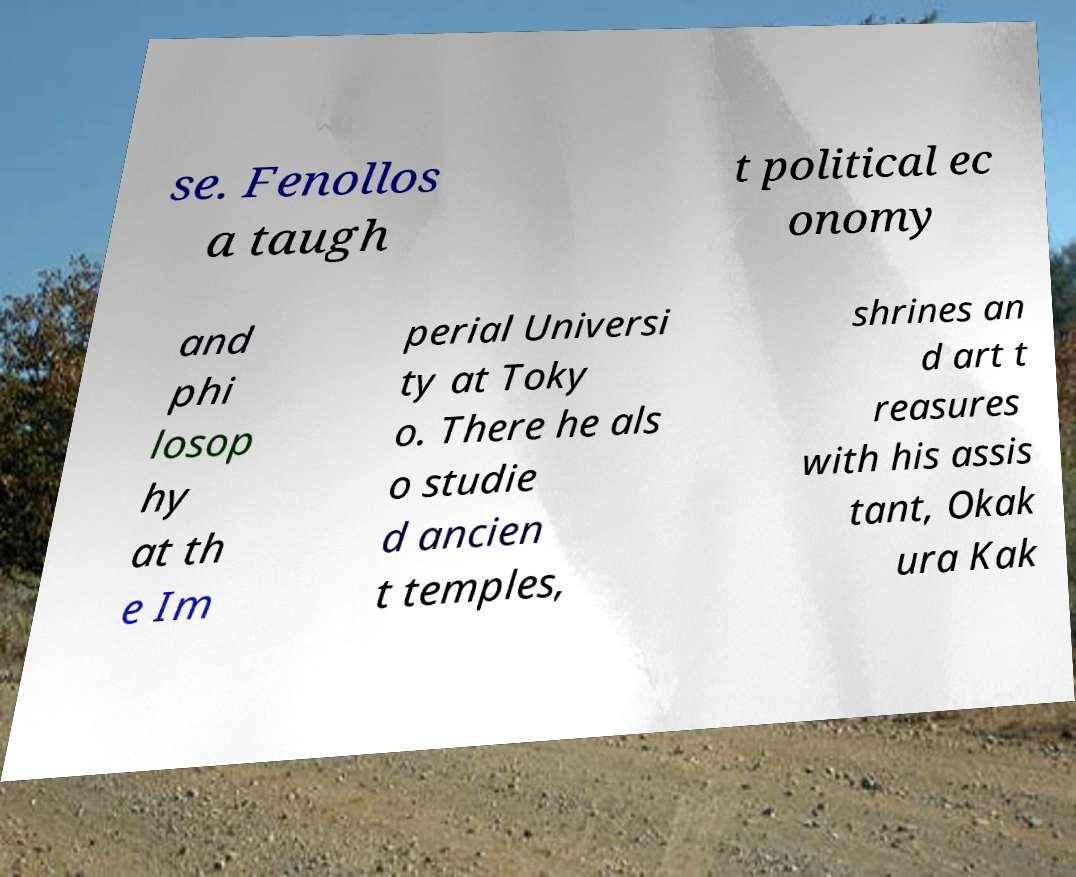There's text embedded in this image that I need extracted. Can you transcribe it verbatim? se. Fenollos a taugh t political ec onomy and phi losop hy at th e Im perial Universi ty at Toky o. There he als o studie d ancien t temples, shrines an d art t reasures with his assis tant, Okak ura Kak 